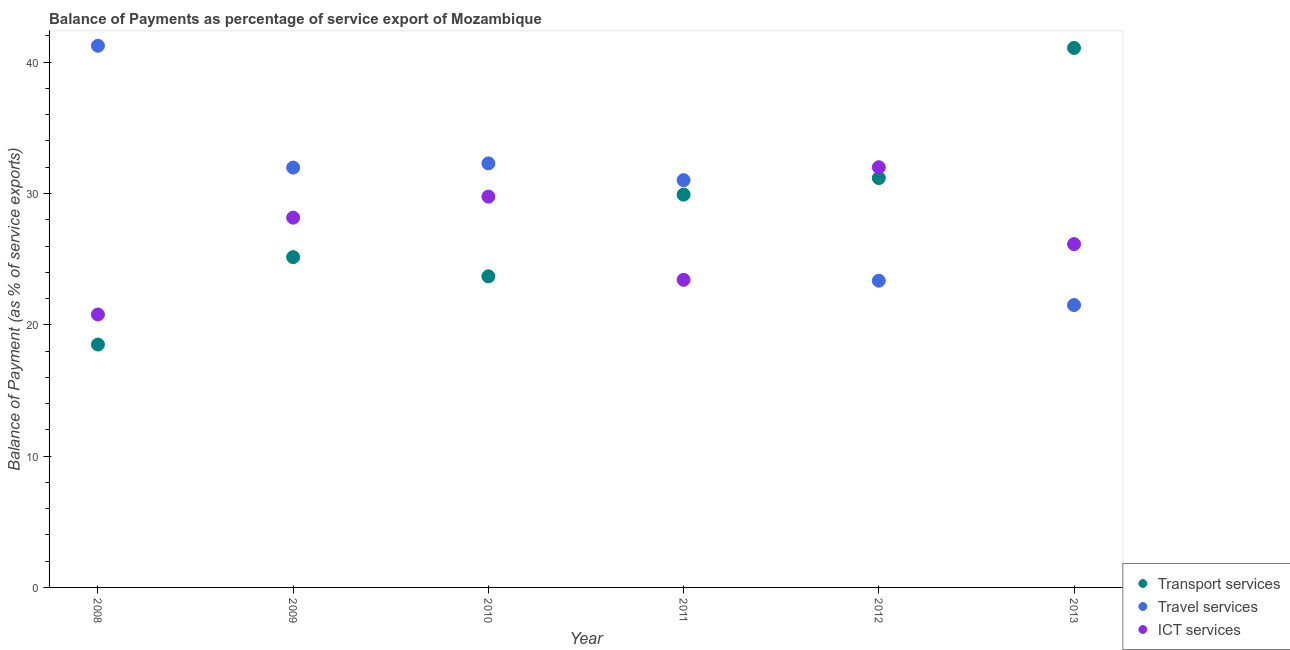How many different coloured dotlines are there?
Your answer should be compact. 3. Is the number of dotlines equal to the number of legend labels?
Provide a short and direct response. Yes. What is the balance of payment of ict services in 2013?
Your answer should be very brief. 26.15. Across all years, what is the maximum balance of payment of transport services?
Your response must be concise. 41.08. Across all years, what is the minimum balance of payment of ict services?
Give a very brief answer. 20.79. In which year was the balance of payment of transport services maximum?
Your answer should be very brief. 2013. What is the total balance of payment of travel services in the graph?
Your response must be concise. 181.4. What is the difference between the balance of payment of ict services in 2009 and that in 2012?
Your answer should be very brief. -3.84. What is the difference between the balance of payment of travel services in 2011 and the balance of payment of ict services in 2008?
Ensure brevity in your answer.  10.23. What is the average balance of payment of transport services per year?
Keep it short and to the point. 28.25. In the year 2008, what is the difference between the balance of payment of travel services and balance of payment of ict services?
Offer a terse response. 20.46. What is the ratio of the balance of payment of transport services in 2008 to that in 2011?
Provide a short and direct response. 0.62. Is the difference between the balance of payment of travel services in 2010 and 2012 greater than the difference between the balance of payment of ict services in 2010 and 2012?
Offer a terse response. Yes. What is the difference between the highest and the second highest balance of payment of ict services?
Your answer should be compact. 2.24. What is the difference between the highest and the lowest balance of payment of transport services?
Your answer should be very brief. 22.59. In how many years, is the balance of payment of travel services greater than the average balance of payment of travel services taken over all years?
Provide a short and direct response. 4. Is the sum of the balance of payment of ict services in 2010 and 2013 greater than the maximum balance of payment of transport services across all years?
Give a very brief answer. Yes. Does the balance of payment of travel services monotonically increase over the years?
Offer a very short reply. No. Is the balance of payment of travel services strictly greater than the balance of payment of transport services over the years?
Your response must be concise. No. Is the balance of payment of ict services strictly less than the balance of payment of transport services over the years?
Provide a succinct answer. No. How many years are there in the graph?
Your answer should be compact. 6. What is the difference between two consecutive major ticks on the Y-axis?
Your response must be concise. 10. Does the graph contain any zero values?
Your answer should be very brief. No. Where does the legend appear in the graph?
Ensure brevity in your answer.  Bottom right. What is the title of the graph?
Your response must be concise. Balance of Payments as percentage of service export of Mozambique. Does "Czech Republic" appear as one of the legend labels in the graph?
Your answer should be compact. No. What is the label or title of the X-axis?
Keep it short and to the point. Year. What is the label or title of the Y-axis?
Your answer should be very brief. Balance of Payment (as % of service exports). What is the Balance of Payment (as % of service exports) of Transport services in 2008?
Provide a short and direct response. 18.5. What is the Balance of Payment (as % of service exports) of Travel services in 2008?
Offer a very short reply. 41.25. What is the Balance of Payment (as % of service exports) in ICT services in 2008?
Make the answer very short. 20.79. What is the Balance of Payment (as % of service exports) in Transport services in 2009?
Provide a succinct answer. 25.15. What is the Balance of Payment (as % of service exports) in Travel services in 2009?
Give a very brief answer. 31.97. What is the Balance of Payment (as % of service exports) in ICT services in 2009?
Make the answer very short. 28.16. What is the Balance of Payment (as % of service exports) in Transport services in 2010?
Give a very brief answer. 23.69. What is the Balance of Payment (as % of service exports) of Travel services in 2010?
Your response must be concise. 32.29. What is the Balance of Payment (as % of service exports) in ICT services in 2010?
Keep it short and to the point. 29.76. What is the Balance of Payment (as % of service exports) of Transport services in 2011?
Give a very brief answer. 29.91. What is the Balance of Payment (as % of service exports) in Travel services in 2011?
Your answer should be compact. 31.02. What is the Balance of Payment (as % of service exports) in ICT services in 2011?
Your answer should be very brief. 23.43. What is the Balance of Payment (as % of service exports) of Transport services in 2012?
Offer a terse response. 31.18. What is the Balance of Payment (as % of service exports) in Travel services in 2012?
Ensure brevity in your answer.  23.36. What is the Balance of Payment (as % of service exports) of ICT services in 2012?
Keep it short and to the point. 32. What is the Balance of Payment (as % of service exports) in Transport services in 2013?
Give a very brief answer. 41.08. What is the Balance of Payment (as % of service exports) of Travel services in 2013?
Make the answer very short. 21.5. What is the Balance of Payment (as % of service exports) in ICT services in 2013?
Your answer should be very brief. 26.15. Across all years, what is the maximum Balance of Payment (as % of service exports) of Transport services?
Provide a short and direct response. 41.08. Across all years, what is the maximum Balance of Payment (as % of service exports) in Travel services?
Provide a succinct answer. 41.25. Across all years, what is the maximum Balance of Payment (as % of service exports) of ICT services?
Ensure brevity in your answer.  32. Across all years, what is the minimum Balance of Payment (as % of service exports) of Transport services?
Provide a short and direct response. 18.5. Across all years, what is the minimum Balance of Payment (as % of service exports) of Travel services?
Ensure brevity in your answer.  21.5. Across all years, what is the minimum Balance of Payment (as % of service exports) in ICT services?
Keep it short and to the point. 20.79. What is the total Balance of Payment (as % of service exports) of Transport services in the graph?
Offer a terse response. 169.52. What is the total Balance of Payment (as % of service exports) of Travel services in the graph?
Your answer should be compact. 181.4. What is the total Balance of Payment (as % of service exports) of ICT services in the graph?
Offer a very short reply. 160.28. What is the difference between the Balance of Payment (as % of service exports) of Transport services in 2008 and that in 2009?
Provide a succinct answer. -6.66. What is the difference between the Balance of Payment (as % of service exports) of Travel services in 2008 and that in 2009?
Keep it short and to the point. 9.28. What is the difference between the Balance of Payment (as % of service exports) in ICT services in 2008 and that in 2009?
Provide a succinct answer. -7.37. What is the difference between the Balance of Payment (as % of service exports) of Transport services in 2008 and that in 2010?
Your answer should be compact. -5.19. What is the difference between the Balance of Payment (as % of service exports) in Travel services in 2008 and that in 2010?
Give a very brief answer. 8.96. What is the difference between the Balance of Payment (as % of service exports) in ICT services in 2008 and that in 2010?
Offer a very short reply. -8.97. What is the difference between the Balance of Payment (as % of service exports) of Transport services in 2008 and that in 2011?
Provide a short and direct response. -11.42. What is the difference between the Balance of Payment (as % of service exports) in Travel services in 2008 and that in 2011?
Make the answer very short. 10.24. What is the difference between the Balance of Payment (as % of service exports) of ICT services in 2008 and that in 2011?
Your response must be concise. -2.64. What is the difference between the Balance of Payment (as % of service exports) of Transport services in 2008 and that in 2012?
Give a very brief answer. -12.68. What is the difference between the Balance of Payment (as % of service exports) of Travel services in 2008 and that in 2012?
Give a very brief answer. 17.89. What is the difference between the Balance of Payment (as % of service exports) of ICT services in 2008 and that in 2012?
Ensure brevity in your answer.  -11.21. What is the difference between the Balance of Payment (as % of service exports) in Transport services in 2008 and that in 2013?
Your response must be concise. -22.59. What is the difference between the Balance of Payment (as % of service exports) of Travel services in 2008 and that in 2013?
Keep it short and to the point. 19.75. What is the difference between the Balance of Payment (as % of service exports) in ICT services in 2008 and that in 2013?
Offer a very short reply. -5.36. What is the difference between the Balance of Payment (as % of service exports) of Transport services in 2009 and that in 2010?
Your answer should be very brief. 1.46. What is the difference between the Balance of Payment (as % of service exports) of Travel services in 2009 and that in 2010?
Provide a succinct answer. -0.32. What is the difference between the Balance of Payment (as % of service exports) of ICT services in 2009 and that in 2010?
Offer a terse response. -1.6. What is the difference between the Balance of Payment (as % of service exports) in Transport services in 2009 and that in 2011?
Give a very brief answer. -4.76. What is the difference between the Balance of Payment (as % of service exports) of Travel services in 2009 and that in 2011?
Your answer should be compact. 0.96. What is the difference between the Balance of Payment (as % of service exports) of ICT services in 2009 and that in 2011?
Your answer should be very brief. 4.73. What is the difference between the Balance of Payment (as % of service exports) of Transport services in 2009 and that in 2012?
Provide a succinct answer. -6.02. What is the difference between the Balance of Payment (as % of service exports) of Travel services in 2009 and that in 2012?
Keep it short and to the point. 8.61. What is the difference between the Balance of Payment (as % of service exports) in ICT services in 2009 and that in 2012?
Offer a very short reply. -3.84. What is the difference between the Balance of Payment (as % of service exports) in Transport services in 2009 and that in 2013?
Offer a terse response. -15.93. What is the difference between the Balance of Payment (as % of service exports) in Travel services in 2009 and that in 2013?
Offer a terse response. 10.47. What is the difference between the Balance of Payment (as % of service exports) of ICT services in 2009 and that in 2013?
Provide a short and direct response. 2.01. What is the difference between the Balance of Payment (as % of service exports) of Transport services in 2010 and that in 2011?
Give a very brief answer. -6.22. What is the difference between the Balance of Payment (as % of service exports) in Travel services in 2010 and that in 2011?
Your answer should be very brief. 1.28. What is the difference between the Balance of Payment (as % of service exports) in ICT services in 2010 and that in 2011?
Offer a very short reply. 6.34. What is the difference between the Balance of Payment (as % of service exports) in Transport services in 2010 and that in 2012?
Provide a succinct answer. -7.49. What is the difference between the Balance of Payment (as % of service exports) in Travel services in 2010 and that in 2012?
Provide a succinct answer. 8.93. What is the difference between the Balance of Payment (as % of service exports) of ICT services in 2010 and that in 2012?
Offer a terse response. -2.24. What is the difference between the Balance of Payment (as % of service exports) in Transport services in 2010 and that in 2013?
Give a very brief answer. -17.39. What is the difference between the Balance of Payment (as % of service exports) of Travel services in 2010 and that in 2013?
Provide a short and direct response. 10.79. What is the difference between the Balance of Payment (as % of service exports) in ICT services in 2010 and that in 2013?
Offer a terse response. 3.62. What is the difference between the Balance of Payment (as % of service exports) of Transport services in 2011 and that in 2012?
Keep it short and to the point. -1.26. What is the difference between the Balance of Payment (as % of service exports) of Travel services in 2011 and that in 2012?
Keep it short and to the point. 7.65. What is the difference between the Balance of Payment (as % of service exports) of ICT services in 2011 and that in 2012?
Offer a very short reply. -8.58. What is the difference between the Balance of Payment (as % of service exports) of Transport services in 2011 and that in 2013?
Give a very brief answer. -11.17. What is the difference between the Balance of Payment (as % of service exports) in Travel services in 2011 and that in 2013?
Your answer should be very brief. 9.51. What is the difference between the Balance of Payment (as % of service exports) of ICT services in 2011 and that in 2013?
Your answer should be very brief. -2.72. What is the difference between the Balance of Payment (as % of service exports) in Transport services in 2012 and that in 2013?
Keep it short and to the point. -9.91. What is the difference between the Balance of Payment (as % of service exports) of Travel services in 2012 and that in 2013?
Your answer should be compact. 1.86. What is the difference between the Balance of Payment (as % of service exports) of ICT services in 2012 and that in 2013?
Offer a very short reply. 5.86. What is the difference between the Balance of Payment (as % of service exports) in Transport services in 2008 and the Balance of Payment (as % of service exports) in Travel services in 2009?
Your answer should be very brief. -13.47. What is the difference between the Balance of Payment (as % of service exports) in Transport services in 2008 and the Balance of Payment (as % of service exports) in ICT services in 2009?
Offer a terse response. -9.66. What is the difference between the Balance of Payment (as % of service exports) in Travel services in 2008 and the Balance of Payment (as % of service exports) in ICT services in 2009?
Your answer should be compact. 13.09. What is the difference between the Balance of Payment (as % of service exports) of Transport services in 2008 and the Balance of Payment (as % of service exports) of Travel services in 2010?
Your answer should be very brief. -13.8. What is the difference between the Balance of Payment (as % of service exports) of Transport services in 2008 and the Balance of Payment (as % of service exports) of ICT services in 2010?
Your response must be concise. -11.26. What is the difference between the Balance of Payment (as % of service exports) in Travel services in 2008 and the Balance of Payment (as % of service exports) in ICT services in 2010?
Your response must be concise. 11.49. What is the difference between the Balance of Payment (as % of service exports) of Transport services in 2008 and the Balance of Payment (as % of service exports) of Travel services in 2011?
Provide a succinct answer. -12.52. What is the difference between the Balance of Payment (as % of service exports) in Transport services in 2008 and the Balance of Payment (as % of service exports) in ICT services in 2011?
Make the answer very short. -4.93. What is the difference between the Balance of Payment (as % of service exports) in Travel services in 2008 and the Balance of Payment (as % of service exports) in ICT services in 2011?
Keep it short and to the point. 17.83. What is the difference between the Balance of Payment (as % of service exports) in Transport services in 2008 and the Balance of Payment (as % of service exports) in Travel services in 2012?
Your response must be concise. -4.86. What is the difference between the Balance of Payment (as % of service exports) of Transport services in 2008 and the Balance of Payment (as % of service exports) of ICT services in 2012?
Your response must be concise. -13.5. What is the difference between the Balance of Payment (as % of service exports) in Travel services in 2008 and the Balance of Payment (as % of service exports) in ICT services in 2012?
Offer a terse response. 9.25. What is the difference between the Balance of Payment (as % of service exports) of Transport services in 2008 and the Balance of Payment (as % of service exports) of Travel services in 2013?
Your answer should be compact. -3.01. What is the difference between the Balance of Payment (as % of service exports) of Transport services in 2008 and the Balance of Payment (as % of service exports) of ICT services in 2013?
Ensure brevity in your answer.  -7.65. What is the difference between the Balance of Payment (as % of service exports) of Travel services in 2008 and the Balance of Payment (as % of service exports) of ICT services in 2013?
Offer a very short reply. 15.11. What is the difference between the Balance of Payment (as % of service exports) of Transport services in 2009 and the Balance of Payment (as % of service exports) of Travel services in 2010?
Your answer should be very brief. -7.14. What is the difference between the Balance of Payment (as % of service exports) in Transport services in 2009 and the Balance of Payment (as % of service exports) in ICT services in 2010?
Give a very brief answer. -4.61. What is the difference between the Balance of Payment (as % of service exports) in Travel services in 2009 and the Balance of Payment (as % of service exports) in ICT services in 2010?
Ensure brevity in your answer.  2.21. What is the difference between the Balance of Payment (as % of service exports) of Transport services in 2009 and the Balance of Payment (as % of service exports) of Travel services in 2011?
Give a very brief answer. -5.86. What is the difference between the Balance of Payment (as % of service exports) of Transport services in 2009 and the Balance of Payment (as % of service exports) of ICT services in 2011?
Your answer should be compact. 1.73. What is the difference between the Balance of Payment (as % of service exports) of Travel services in 2009 and the Balance of Payment (as % of service exports) of ICT services in 2011?
Provide a short and direct response. 8.55. What is the difference between the Balance of Payment (as % of service exports) in Transport services in 2009 and the Balance of Payment (as % of service exports) in Travel services in 2012?
Offer a terse response. 1.79. What is the difference between the Balance of Payment (as % of service exports) in Transport services in 2009 and the Balance of Payment (as % of service exports) in ICT services in 2012?
Your answer should be very brief. -6.85. What is the difference between the Balance of Payment (as % of service exports) in Travel services in 2009 and the Balance of Payment (as % of service exports) in ICT services in 2012?
Give a very brief answer. -0.03. What is the difference between the Balance of Payment (as % of service exports) in Transport services in 2009 and the Balance of Payment (as % of service exports) in Travel services in 2013?
Give a very brief answer. 3.65. What is the difference between the Balance of Payment (as % of service exports) of Transport services in 2009 and the Balance of Payment (as % of service exports) of ICT services in 2013?
Ensure brevity in your answer.  -0.99. What is the difference between the Balance of Payment (as % of service exports) of Travel services in 2009 and the Balance of Payment (as % of service exports) of ICT services in 2013?
Offer a terse response. 5.83. What is the difference between the Balance of Payment (as % of service exports) in Transport services in 2010 and the Balance of Payment (as % of service exports) in Travel services in 2011?
Your answer should be very brief. -7.32. What is the difference between the Balance of Payment (as % of service exports) of Transport services in 2010 and the Balance of Payment (as % of service exports) of ICT services in 2011?
Make the answer very short. 0.27. What is the difference between the Balance of Payment (as % of service exports) in Travel services in 2010 and the Balance of Payment (as % of service exports) in ICT services in 2011?
Give a very brief answer. 8.87. What is the difference between the Balance of Payment (as % of service exports) in Transport services in 2010 and the Balance of Payment (as % of service exports) in Travel services in 2012?
Your answer should be very brief. 0.33. What is the difference between the Balance of Payment (as % of service exports) in Transport services in 2010 and the Balance of Payment (as % of service exports) in ICT services in 2012?
Provide a short and direct response. -8.31. What is the difference between the Balance of Payment (as % of service exports) in Travel services in 2010 and the Balance of Payment (as % of service exports) in ICT services in 2012?
Provide a succinct answer. 0.29. What is the difference between the Balance of Payment (as % of service exports) in Transport services in 2010 and the Balance of Payment (as % of service exports) in Travel services in 2013?
Offer a very short reply. 2.19. What is the difference between the Balance of Payment (as % of service exports) of Transport services in 2010 and the Balance of Payment (as % of service exports) of ICT services in 2013?
Your response must be concise. -2.45. What is the difference between the Balance of Payment (as % of service exports) of Travel services in 2010 and the Balance of Payment (as % of service exports) of ICT services in 2013?
Provide a succinct answer. 6.15. What is the difference between the Balance of Payment (as % of service exports) in Transport services in 2011 and the Balance of Payment (as % of service exports) in Travel services in 2012?
Offer a terse response. 6.55. What is the difference between the Balance of Payment (as % of service exports) of Transport services in 2011 and the Balance of Payment (as % of service exports) of ICT services in 2012?
Your response must be concise. -2.09. What is the difference between the Balance of Payment (as % of service exports) of Travel services in 2011 and the Balance of Payment (as % of service exports) of ICT services in 2012?
Keep it short and to the point. -0.99. What is the difference between the Balance of Payment (as % of service exports) of Transport services in 2011 and the Balance of Payment (as % of service exports) of Travel services in 2013?
Ensure brevity in your answer.  8.41. What is the difference between the Balance of Payment (as % of service exports) of Transport services in 2011 and the Balance of Payment (as % of service exports) of ICT services in 2013?
Provide a succinct answer. 3.77. What is the difference between the Balance of Payment (as % of service exports) in Travel services in 2011 and the Balance of Payment (as % of service exports) in ICT services in 2013?
Offer a terse response. 4.87. What is the difference between the Balance of Payment (as % of service exports) of Transport services in 2012 and the Balance of Payment (as % of service exports) of Travel services in 2013?
Your response must be concise. 9.67. What is the difference between the Balance of Payment (as % of service exports) of Transport services in 2012 and the Balance of Payment (as % of service exports) of ICT services in 2013?
Offer a very short reply. 5.03. What is the difference between the Balance of Payment (as % of service exports) in Travel services in 2012 and the Balance of Payment (as % of service exports) in ICT services in 2013?
Your response must be concise. -2.78. What is the average Balance of Payment (as % of service exports) in Transport services per year?
Ensure brevity in your answer.  28.25. What is the average Balance of Payment (as % of service exports) in Travel services per year?
Offer a very short reply. 30.23. What is the average Balance of Payment (as % of service exports) in ICT services per year?
Keep it short and to the point. 26.71. In the year 2008, what is the difference between the Balance of Payment (as % of service exports) in Transport services and Balance of Payment (as % of service exports) in Travel services?
Give a very brief answer. -22.75. In the year 2008, what is the difference between the Balance of Payment (as % of service exports) in Transport services and Balance of Payment (as % of service exports) in ICT services?
Ensure brevity in your answer.  -2.29. In the year 2008, what is the difference between the Balance of Payment (as % of service exports) of Travel services and Balance of Payment (as % of service exports) of ICT services?
Give a very brief answer. 20.46. In the year 2009, what is the difference between the Balance of Payment (as % of service exports) of Transport services and Balance of Payment (as % of service exports) of Travel services?
Your answer should be very brief. -6.82. In the year 2009, what is the difference between the Balance of Payment (as % of service exports) in Transport services and Balance of Payment (as % of service exports) in ICT services?
Keep it short and to the point. -3.01. In the year 2009, what is the difference between the Balance of Payment (as % of service exports) in Travel services and Balance of Payment (as % of service exports) in ICT services?
Offer a terse response. 3.81. In the year 2010, what is the difference between the Balance of Payment (as % of service exports) in Transport services and Balance of Payment (as % of service exports) in Travel services?
Offer a very short reply. -8.6. In the year 2010, what is the difference between the Balance of Payment (as % of service exports) of Transport services and Balance of Payment (as % of service exports) of ICT services?
Provide a succinct answer. -6.07. In the year 2010, what is the difference between the Balance of Payment (as % of service exports) of Travel services and Balance of Payment (as % of service exports) of ICT services?
Ensure brevity in your answer.  2.53. In the year 2011, what is the difference between the Balance of Payment (as % of service exports) of Transport services and Balance of Payment (as % of service exports) of Travel services?
Offer a very short reply. -1.1. In the year 2011, what is the difference between the Balance of Payment (as % of service exports) in Transport services and Balance of Payment (as % of service exports) in ICT services?
Your answer should be compact. 6.49. In the year 2011, what is the difference between the Balance of Payment (as % of service exports) of Travel services and Balance of Payment (as % of service exports) of ICT services?
Offer a very short reply. 7.59. In the year 2012, what is the difference between the Balance of Payment (as % of service exports) of Transport services and Balance of Payment (as % of service exports) of Travel services?
Offer a very short reply. 7.82. In the year 2012, what is the difference between the Balance of Payment (as % of service exports) in Transport services and Balance of Payment (as % of service exports) in ICT services?
Your answer should be compact. -0.82. In the year 2012, what is the difference between the Balance of Payment (as % of service exports) of Travel services and Balance of Payment (as % of service exports) of ICT services?
Offer a very short reply. -8.64. In the year 2013, what is the difference between the Balance of Payment (as % of service exports) in Transport services and Balance of Payment (as % of service exports) in Travel services?
Provide a short and direct response. 19.58. In the year 2013, what is the difference between the Balance of Payment (as % of service exports) of Transport services and Balance of Payment (as % of service exports) of ICT services?
Your answer should be very brief. 14.94. In the year 2013, what is the difference between the Balance of Payment (as % of service exports) in Travel services and Balance of Payment (as % of service exports) in ICT services?
Provide a succinct answer. -4.64. What is the ratio of the Balance of Payment (as % of service exports) in Transport services in 2008 to that in 2009?
Give a very brief answer. 0.74. What is the ratio of the Balance of Payment (as % of service exports) in Travel services in 2008 to that in 2009?
Keep it short and to the point. 1.29. What is the ratio of the Balance of Payment (as % of service exports) of ICT services in 2008 to that in 2009?
Make the answer very short. 0.74. What is the ratio of the Balance of Payment (as % of service exports) in Transport services in 2008 to that in 2010?
Give a very brief answer. 0.78. What is the ratio of the Balance of Payment (as % of service exports) in Travel services in 2008 to that in 2010?
Offer a very short reply. 1.28. What is the ratio of the Balance of Payment (as % of service exports) of ICT services in 2008 to that in 2010?
Keep it short and to the point. 0.7. What is the ratio of the Balance of Payment (as % of service exports) in Transport services in 2008 to that in 2011?
Your answer should be compact. 0.62. What is the ratio of the Balance of Payment (as % of service exports) of Travel services in 2008 to that in 2011?
Offer a very short reply. 1.33. What is the ratio of the Balance of Payment (as % of service exports) of ICT services in 2008 to that in 2011?
Your answer should be very brief. 0.89. What is the ratio of the Balance of Payment (as % of service exports) in Transport services in 2008 to that in 2012?
Ensure brevity in your answer.  0.59. What is the ratio of the Balance of Payment (as % of service exports) in Travel services in 2008 to that in 2012?
Offer a very short reply. 1.77. What is the ratio of the Balance of Payment (as % of service exports) of ICT services in 2008 to that in 2012?
Your response must be concise. 0.65. What is the ratio of the Balance of Payment (as % of service exports) in Transport services in 2008 to that in 2013?
Your response must be concise. 0.45. What is the ratio of the Balance of Payment (as % of service exports) in Travel services in 2008 to that in 2013?
Your answer should be compact. 1.92. What is the ratio of the Balance of Payment (as % of service exports) of ICT services in 2008 to that in 2013?
Offer a terse response. 0.8. What is the ratio of the Balance of Payment (as % of service exports) of Transport services in 2009 to that in 2010?
Provide a succinct answer. 1.06. What is the ratio of the Balance of Payment (as % of service exports) of Travel services in 2009 to that in 2010?
Offer a very short reply. 0.99. What is the ratio of the Balance of Payment (as % of service exports) of ICT services in 2009 to that in 2010?
Keep it short and to the point. 0.95. What is the ratio of the Balance of Payment (as % of service exports) in Transport services in 2009 to that in 2011?
Your response must be concise. 0.84. What is the ratio of the Balance of Payment (as % of service exports) of Travel services in 2009 to that in 2011?
Your response must be concise. 1.03. What is the ratio of the Balance of Payment (as % of service exports) of ICT services in 2009 to that in 2011?
Ensure brevity in your answer.  1.2. What is the ratio of the Balance of Payment (as % of service exports) of Transport services in 2009 to that in 2012?
Your response must be concise. 0.81. What is the ratio of the Balance of Payment (as % of service exports) in Travel services in 2009 to that in 2012?
Give a very brief answer. 1.37. What is the ratio of the Balance of Payment (as % of service exports) in ICT services in 2009 to that in 2012?
Offer a very short reply. 0.88. What is the ratio of the Balance of Payment (as % of service exports) of Transport services in 2009 to that in 2013?
Provide a short and direct response. 0.61. What is the ratio of the Balance of Payment (as % of service exports) of Travel services in 2009 to that in 2013?
Your answer should be very brief. 1.49. What is the ratio of the Balance of Payment (as % of service exports) in ICT services in 2009 to that in 2013?
Provide a succinct answer. 1.08. What is the ratio of the Balance of Payment (as % of service exports) in Transport services in 2010 to that in 2011?
Your response must be concise. 0.79. What is the ratio of the Balance of Payment (as % of service exports) of Travel services in 2010 to that in 2011?
Ensure brevity in your answer.  1.04. What is the ratio of the Balance of Payment (as % of service exports) of ICT services in 2010 to that in 2011?
Your answer should be compact. 1.27. What is the ratio of the Balance of Payment (as % of service exports) in Transport services in 2010 to that in 2012?
Your response must be concise. 0.76. What is the ratio of the Balance of Payment (as % of service exports) of Travel services in 2010 to that in 2012?
Your answer should be compact. 1.38. What is the ratio of the Balance of Payment (as % of service exports) in Transport services in 2010 to that in 2013?
Ensure brevity in your answer.  0.58. What is the ratio of the Balance of Payment (as % of service exports) of Travel services in 2010 to that in 2013?
Offer a terse response. 1.5. What is the ratio of the Balance of Payment (as % of service exports) of ICT services in 2010 to that in 2013?
Provide a succinct answer. 1.14. What is the ratio of the Balance of Payment (as % of service exports) in Transport services in 2011 to that in 2012?
Your answer should be very brief. 0.96. What is the ratio of the Balance of Payment (as % of service exports) of Travel services in 2011 to that in 2012?
Your answer should be very brief. 1.33. What is the ratio of the Balance of Payment (as % of service exports) of ICT services in 2011 to that in 2012?
Ensure brevity in your answer.  0.73. What is the ratio of the Balance of Payment (as % of service exports) in Transport services in 2011 to that in 2013?
Offer a very short reply. 0.73. What is the ratio of the Balance of Payment (as % of service exports) in Travel services in 2011 to that in 2013?
Provide a short and direct response. 1.44. What is the ratio of the Balance of Payment (as % of service exports) in ICT services in 2011 to that in 2013?
Ensure brevity in your answer.  0.9. What is the ratio of the Balance of Payment (as % of service exports) of Transport services in 2012 to that in 2013?
Your response must be concise. 0.76. What is the ratio of the Balance of Payment (as % of service exports) of Travel services in 2012 to that in 2013?
Your answer should be very brief. 1.09. What is the ratio of the Balance of Payment (as % of service exports) in ICT services in 2012 to that in 2013?
Your answer should be compact. 1.22. What is the difference between the highest and the second highest Balance of Payment (as % of service exports) of Transport services?
Offer a very short reply. 9.91. What is the difference between the highest and the second highest Balance of Payment (as % of service exports) in Travel services?
Provide a succinct answer. 8.96. What is the difference between the highest and the second highest Balance of Payment (as % of service exports) in ICT services?
Keep it short and to the point. 2.24. What is the difference between the highest and the lowest Balance of Payment (as % of service exports) of Transport services?
Your response must be concise. 22.59. What is the difference between the highest and the lowest Balance of Payment (as % of service exports) in Travel services?
Your response must be concise. 19.75. What is the difference between the highest and the lowest Balance of Payment (as % of service exports) of ICT services?
Ensure brevity in your answer.  11.21. 